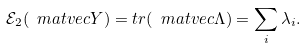Convert formula to latex. <formula><loc_0><loc_0><loc_500><loc_500>\mathcal { E } _ { 2 } ( \ m a t v e c { Y } ) = t r ( \ m a t v e c { \Lambda } ) = \sum _ { i } \lambda _ { i } .</formula> 